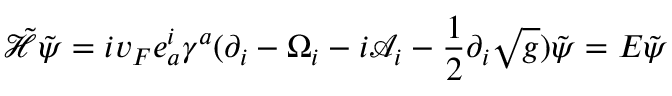<formula> <loc_0><loc_0><loc_500><loc_500>\tilde { \mathcal { H } } \tilde { \psi } = i v _ { F } e _ { a } ^ { i } \gamma ^ { a } ( \partial _ { i } - \Omega _ { i } - i \mathcal { A } _ { i } - \frac { 1 } { 2 } \partial _ { i } \sqrt { g } ) \tilde { \psi } = E \tilde { \psi }</formula> 